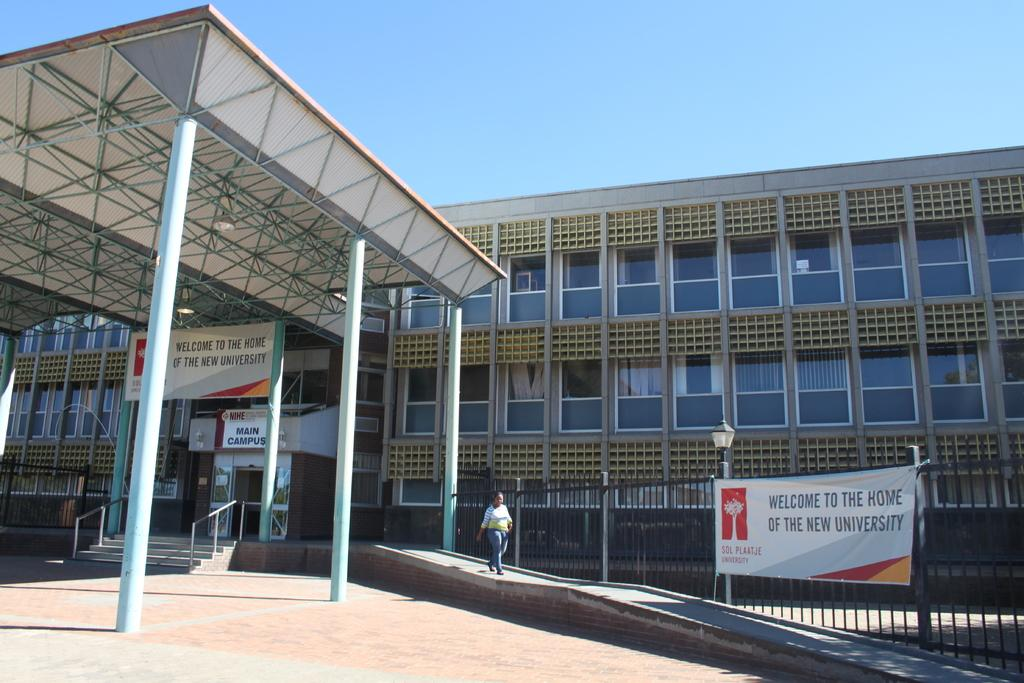What type of structure is visible in the image? There is a building in the image. What materials are used in the construction of the structure? Metal rods are visible in the image, which may be part of the building's construction. What other elements can be seen in the image? There are lights and hoardings in the image. Is there is any barrier or enclosure in front of the building? Yes, there is a fence in front of the building. Who or what is located in front of the building? There is a woman in front of the building. What type of loss is the writer experiencing in the image? There is no writer or loss mentioned in the image. The image features a building, metal rods, lights, hoardings, a fence, and a woman. 